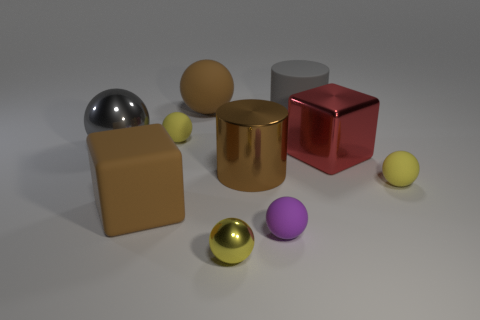What size is the other metallic object that is the same shape as the tiny yellow shiny thing?
Keep it short and to the point. Large. There is a matte ball in front of the large brown cube; does it have the same size as the yellow thing that is right of the brown metallic cylinder?
Provide a succinct answer. Yes. There is a large thing that is both in front of the large gray matte cylinder and to the right of the shiny cylinder; what is its material?
Offer a terse response. Metal. What number of yellow rubber spheres are behind the big gray ball?
Ensure brevity in your answer.  1. Are there any other things that are the same size as the red block?
Offer a terse response. Yes. What is the color of the big ball that is the same material as the large brown block?
Provide a short and direct response. Brown. Is the large red metal object the same shape as the purple object?
Offer a very short reply. No. What number of balls are in front of the rubber cylinder and behind the small yellow metallic sphere?
Keep it short and to the point. 4. How many metal things are brown blocks or small red objects?
Your response must be concise. 0. There is a yellow rubber ball in front of the tiny yellow rubber sphere to the left of the tiny yellow shiny ball; how big is it?
Provide a short and direct response. Small. 